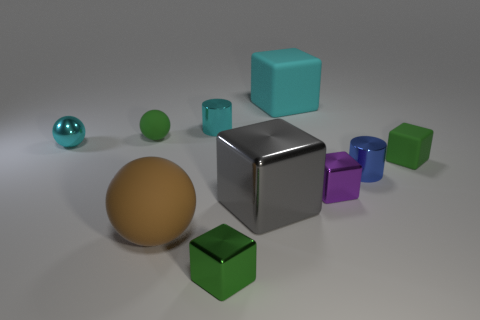Subtract all big gray shiny blocks. How many blocks are left? 4 Subtract all purple cubes. How many cubes are left? 4 Subtract all red cubes. Subtract all yellow cylinders. How many cubes are left? 5 Subtract all balls. How many objects are left? 7 Subtract all large brown objects. Subtract all small cyan metal objects. How many objects are left? 7 Add 6 large brown objects. How many large brown objects are left? 7 Add 3 purple metallic things. How many purple metallic things exist? 4 Subtract 1 purple cubes. How many objects are left? 9 